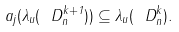<formula> <loc_0><loc_0><loc_500><loc_500>a _ { j } ( \lambda _ { u } ( \ D _ { n } ^ { k + 1 } ) ) \subseteq \lambda _ { u } ( \ D _ { n } ^ { k } ) .</formula> 